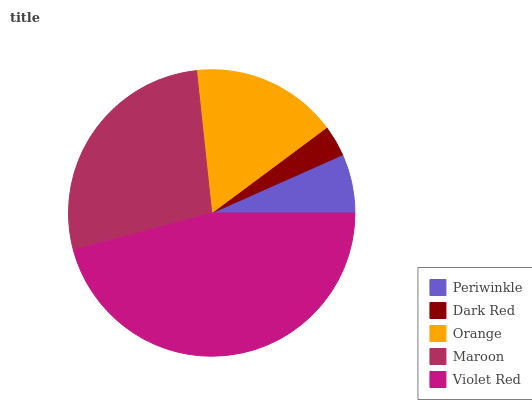Is Dark Red the minimum?
Answer yes or no. Yes. Is Violet Red the maximum?
Answer yes or no. Yes. Is Orange the minimum?
Answer yes or no. No. Is Orange the maximum?
Answer yes or no. No. Is Orange greater than Dark Red?
Answer yes or no. Yes. Is Dark Red less than Orange?
Answer yes or no. Yes. Is Dark Red greater than Orange?
Answer yes or no. No. Is Orange less than Dark Red?
Answer yes or no. No. Is Orange the high median?
Answer yes or no. Yes. Is Orange the low median?
Answer yes or no. Yes. Is Dark Red the high median?
Answer yes or no. No. Is Maroon the low median?
Answer yes or no. No. 